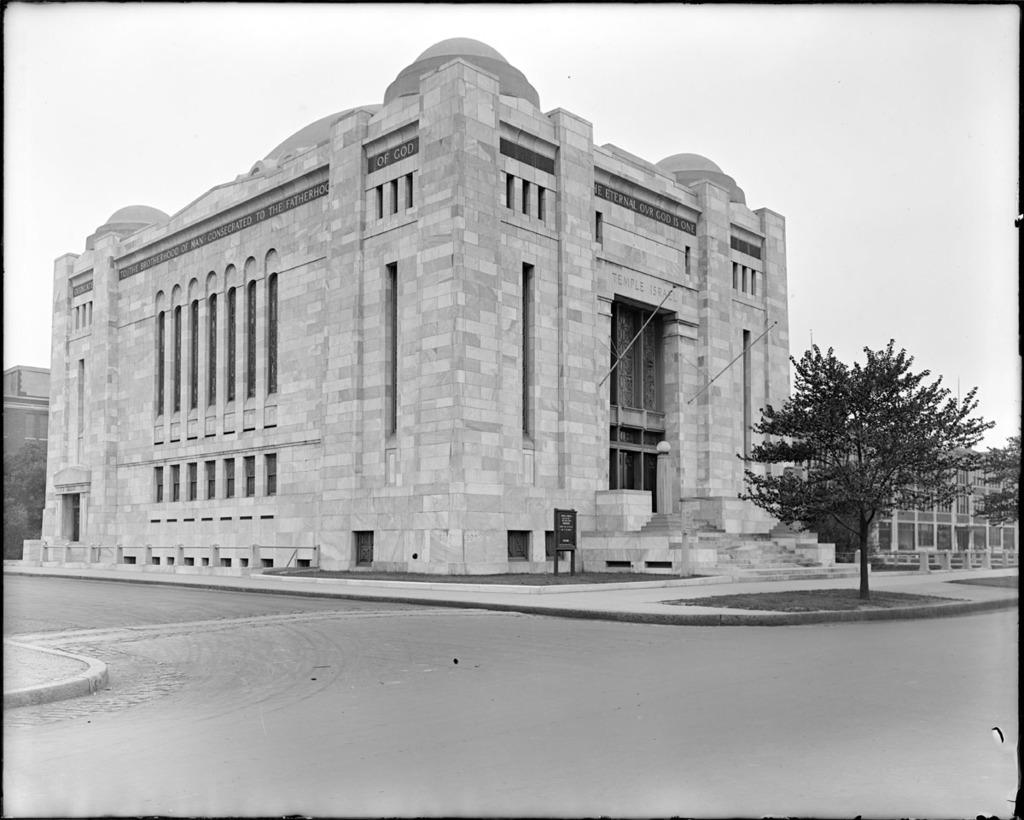What type of path can be seen in the image? There are footpaths in the image. What is located alongside the footpaths? There is a road in the image. What type of vegetation is present in the image? There are trees in the image. What type of structures can be seen in the image? There are buildings in the image. What is the purpose of the board in the image? The purpose of the board in the image is not specified, but it could be a sign or advertisement. What type of barrier is present in the image? There is a fence in the image. What other objects can be seen in the image? There are some objects in the image, but their specific nature is not mentioned. What can be seen in the background of the image? The sky is visible in the background of the image. How many crows are sitting on the fence in the image? There are no crows present in the image; it features a road, footpaths, trees, buildings, a board, a fence, and some objects, but no crows. Are there any bears visible in the image? There are no bears present in the image. 